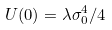Convert formula to latex. <formula><loc_0><loc_0><loc_500><loc_500>U ( 0 ) = \lambda \sigma _ { 0 } ^ { 4 } / 4</formula> 